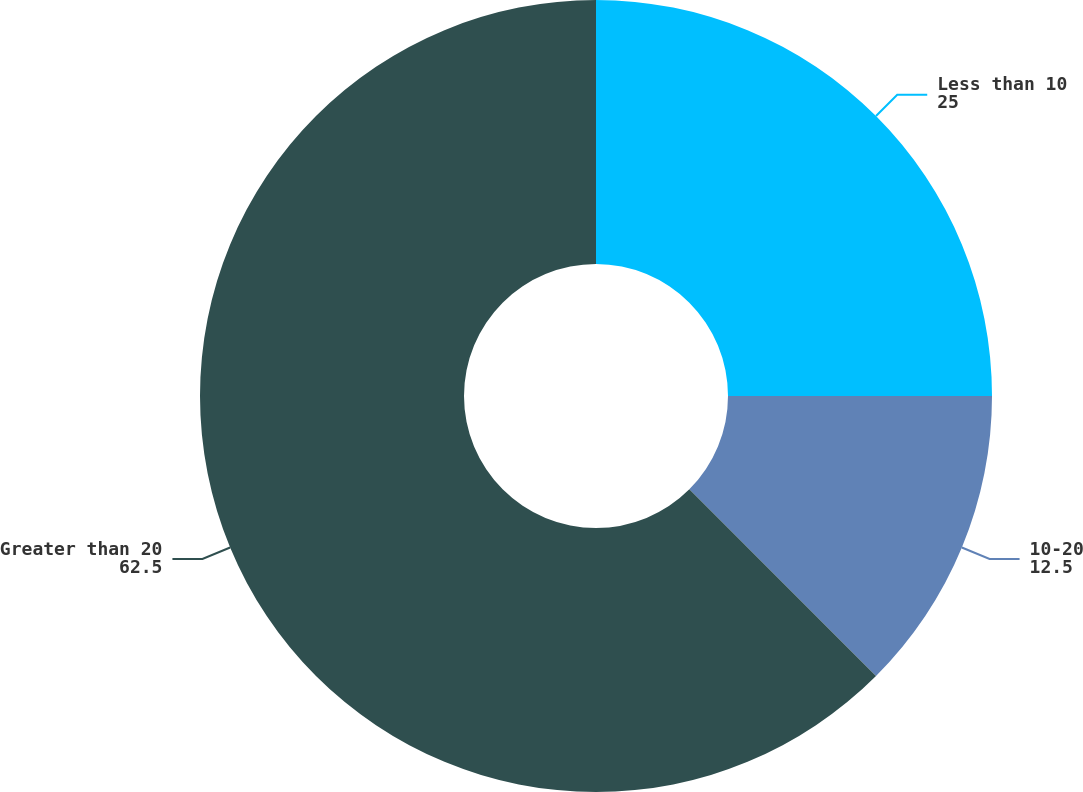<chart> <loc_0><loc_0><loc_500><loc_500><pie_chart><fcel>Less than 10<fcel>10-20<fcel>Greater than 20<nl><fcel>25.0%<fcel>12.5%<fcel>62.5%<nl></chart> 